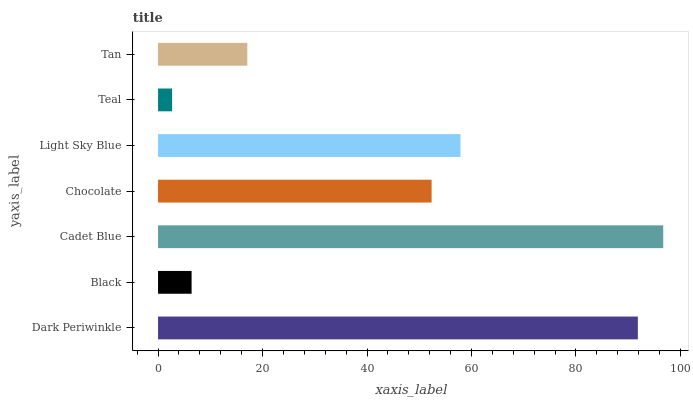Is Teal the minimum?
Answer yes or no. Yes. Is Cadet Blue the maximum?
Answer yes or no. Yes. Is Black the minimum?
Answer yes or no. No. Is Black the maximum?
Answer yes or no. No. Is Dark Periwinkle greater than Black?
Answer yes or no. Yes. Is Black less than Dark Periwinkle?
Answer yes or no. Yes. Is Black greater than Dark Periwinkle?
Answer yes or no. No. Is Dark Periwinkle less than Black?
Answer yes or no. No. Is Chocolate the high median?
Answer yes or no. Yes. Is Chocolate the low median?
Answer yes or no. Yes. Is Dark Periwinkle the high median?
Answer yes or no. No. Is Tan the low median?
Answer yes or no. No. 